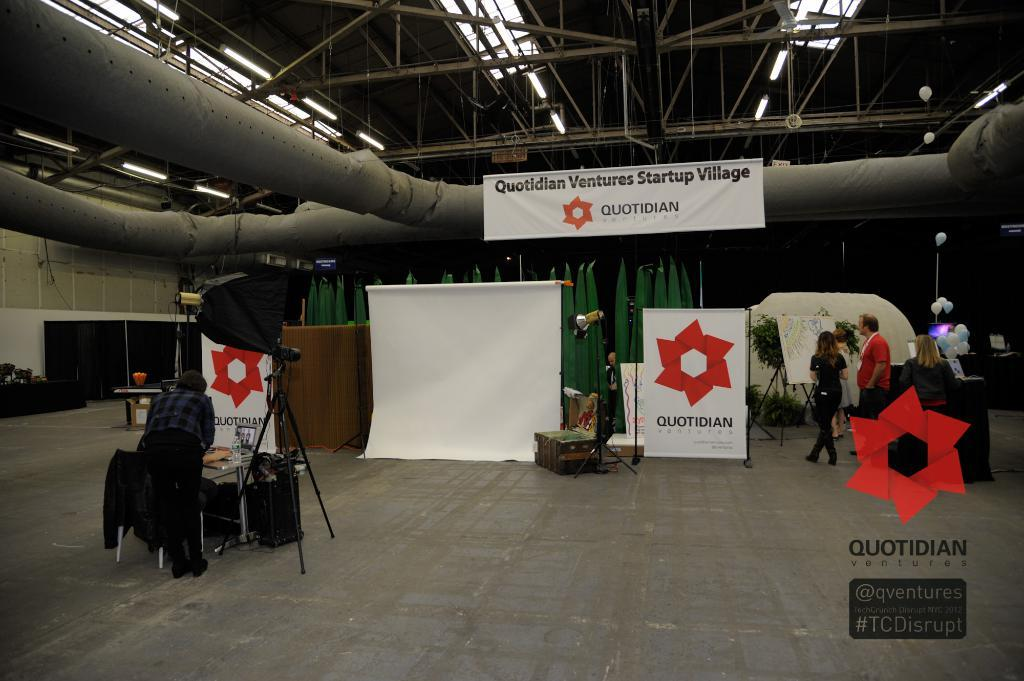<image>
Present a compact description of the photo's key features. A group of people setting up for a photo shoot associated with Quotidian Ventures Startup Village. 